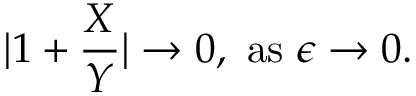<formula> <loc_0><loc_0><loc_500><loc_500>| 1 + { \frac { X } { Y } } | \to 0 , \ a s \ \epsilon \to 0 .</formula> 